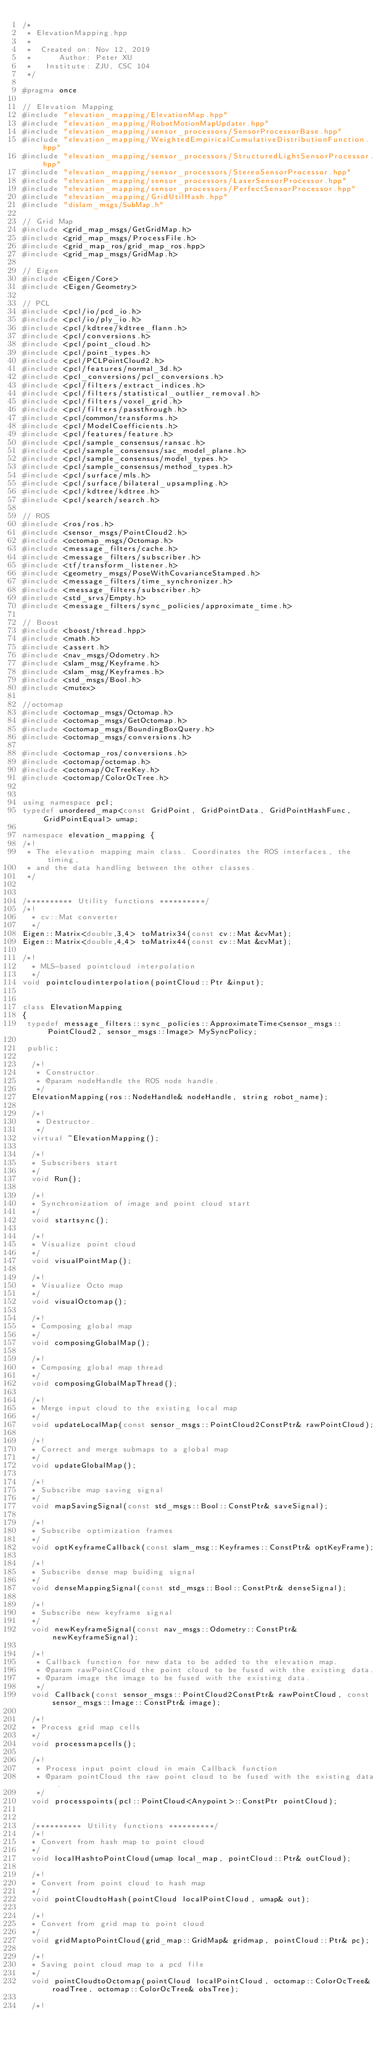<code> <loc_0><loc_0><loc_500><loc_500><_C++_>/*
 * ElevationMapping.hpp
 *
 *  Created on: Nov 12, 2019
 *      Author: Peter XU
 *	 Institute: ZJU, CSC 104
 */

#pragma once

// Elevation Mapping
#include "elevation_mapping/ElevationMap.hpp"
#include "elevation_mapping/RobotMotionMapUpdater.hpp"
#include "elevation_mapping/sensor_processors/SensorProcessorBase.hpp"
#include "elevation_mapping/WeightedEmpiricalCumulativeDistributionFunction.hpp"
#include "elevation_mapping/sensor_processors/StructuredLightSensorProcessor.hpp"
#include "elevation_mapping/sensor_processors/StereoSensorProcessor.hpp"
#include "elevation_mapping/sensor_processors/LaserSensorProcessor.hpp"
#include "elevation_mapping/sensor_processors/PerfectSensorProcessor.hpp"
#include "elevation_mapping/GridUtilHash.hpp"
#include "dislam_msgs/SubMap.h"

// Grid Map
#include <grid_map_msgs/GetGridMap.h>
#include <grid_map_msgs/ProcessFile.h>
#include <grid_map_ros/grid_map_ros.hpp>
#include <grid_map_msgs/GridMap.h>

// Eigen
#include <Eigen/Core>
#include <Eigen/Geometry>

// PCL
#include <pcl/io/pcd_io.h>
#include <pcl/io/ply_io.h>
#include <pcl/kdtree/kdtree_flann.h>
#include <pcl/conversions.h>
#include <pcl/point_cloud.h>
#include <pcl/point_types.h>
#include <pcl/PCLPointCloud2.h>
#include <pcl/features/normal_3d.h>
#include <pcl_conversions/pcl_conversions.h>
#include <pcl/filters/extract_indices.h>
#include <pcl/filters/statistical_outlier_removal.h>
#include <pcl/filters/voxel_grid.h>
#include <pcl/filters/passthrough.h>
#include <pcl/common/transforms.h> 
#include <pcl/ModelCoefficients.h>
#include <pcl/features/feature.h>
#include <pcl/sample_consensus/ransac.h>
#include <pcl/sample_consensus/sac_model_plane.h>
#include <pcl/sample_consensus/model_types.h>
#include <pcl/sample_consensus/method_types.h>
#include <pcl/surface/mls.h>
#include <pcl/surface/bilateral_upsampling.h>
#include <pcl/kdtree/kdtree.h>
#include <pcl/search/search.h>

// ROS
#include <ros/ros.h>
#include <sensor_msgs/PointCloud2.h>
#include <octomap_msgs/Octomap.h>
#include <message_filters/cache.h>
#include <message_filters/subscriber.h>
#include <tf/transform_listener.h>
#include <geometry_msgs/PoseWithCovarianceStamped.h>
#include <message_filters/time_synchronizer.h>
#include <message_filters/subscriber.h>
#include <std_srvs/Empty.h>
#include <message_filters/sync_policies/approximate_time.h>

// Boost
#include <boost/thread.hpp>
#include <math.h>
#include <assert.h>
#include <nav_msgs/Odometry.h>
#include <slam_msg/Keyframe.h>
#include <slam_msg/Keyframes.h>
#include <std_msgs/Bool.h>
#include <mutex>

//octomap
#include <octomap_msgs/Octomap.h>
#include <octomap_msgs/GetOctomap.h>
#include <octomap_msgs/BoundingBoxQuery.h>
#include <octomap_msgs/conversions.h>

#include <octomap_ros/conversions.h>
#include <octomap/octomap.h>
#include <octomap/OcTreeKey.h>
#include <octomap/ColorOcTree.h>


using namespace pcl;
typedef unordered_map<const GridPoint, GridPointData, GridPointHashFunc, GridPointEqual> umap;

namespace elevation_mapping {
/*!
 * The elevation mapping main class. Coordinates the ROS interfaces, the timing,
 * and the data handling between the other classes.
 */


/********** Utility functions **********/
/*!
  * cv::Mat converter
  */
Eigen::Matrix<double,3,4> toMatrix34(const cv::Mat &cvMat);
Eigen::Matrix<double,4,4> toMatrix44(const cv::Mat &cvMat);

/*!
  * MLS-based pointcloud interpolation
  */
void pointcloudinterpolation(pointCloud::Ptr &input);


class ElevationMapping
{
 typedef message_filters::sync_policies::ApproximateTime<sensor_msgs::PointCloud2, sensor_msgs::Image> MySyncPolicy;

 public:

  /*!
   * Constructor.
   * @param nodeHandle the ROS node handle.
   */
  ElevationMapping(ros::NodeHandle& nodeHandle, string robot_name);

  /*!
   * Destructor.
   */
  virtual ~ElevationMapping();

  /*!
  * Subscribers start
  */
  void Run();

  /*!
  * Synchronization of image and point cloud start
  */  
  void startsync();

  /*!
  * Visualize point cloud
  */
  void visualPointMap();

  /*!
  * Visualize Octo map
  */
  void visualOctomap();

  /*!
  * Composing global map
  */
  void composingGlobalMap();

  /*!
  * Composing global map thread
  */
  void composingGlobalMapThread();

  /*!
  * Merge input cloud to the existing local map
  */
  void updateLocalMap(const sensor_msgs::PointCloud2ConstPtr& rawPointCloud);
    
  /*!
  * Correct and merge submaps to a global map
  */
  void updateGlobalMap();
  
  /*!
  * Subscribe map saving signal
  */
  void mapSavingSignal(const std_msgs::Bool::ConstPtr& saveSignal);
    
  /*!
  * Subscribe optimization frames
  */ 
  void optKeyframeCallback(const slam_msg::Keyframes::ConstPtr& optKeyFrame);

  /*!
  * Subscribe dense map buiding signal
  */
  void denseMappingSignal(const std_msgs::Bool::ConstPtr& denseSignal);
  
  /*!
  * Subscribe new keyframe signal
  */ 
  void newKeyframeSignal(const nav_msgs::Odometry::ConstPtr& newKeyframeSignal);

  /*!
   * Callback function for new data to be added to the elevation map.
   * @param rawPointCloud the point cloud to be fused with the existing data.
   * @param image the image to be fused with the existing data.
   */
  void Callback(const sensor_msgs::PointCloud2ConstPtr& rawPointCloud, const sensor_msgs::Image::ConstPtr& image);
  
  /*!
  * Process grid map cells
  */
  void processmapcells();

  /*!
   * Process input point cloud in main Callback function
   * @param pointCloud the raw point cloud to be fused with the existing data.
   */
  void processpoints(pcl::PointCloud<Anypoint>::ConstPtr pointCloud);
  

  /********** Utility functions **********/
  /*!
  * Convert from hash map to point cloud
  */  
  void localHashtoPointCloud(umap local_map, pointCloud::Ptr& outCloud);
  
  /*!
  * Convert from point cloud to hash map
  */  
  void pointCloudtoHash(pointCloud localPointCloud, umap& out);
  
  /*!
  * Convert from grid map to point cloud
  */
  void gridMaptoPointCloud(grid_map::GridMap& gridmap, pointCloud::Ptr& pc);
  
  /*!
  * Saving point cloud map to a pcd file
  */
  void pointCloudtoOctomap(pointCloud localPointCloud, octomap::ColorOcTree& roadTree, octomap::ColorOcTree& obsTree);
  
  /*!</code> 